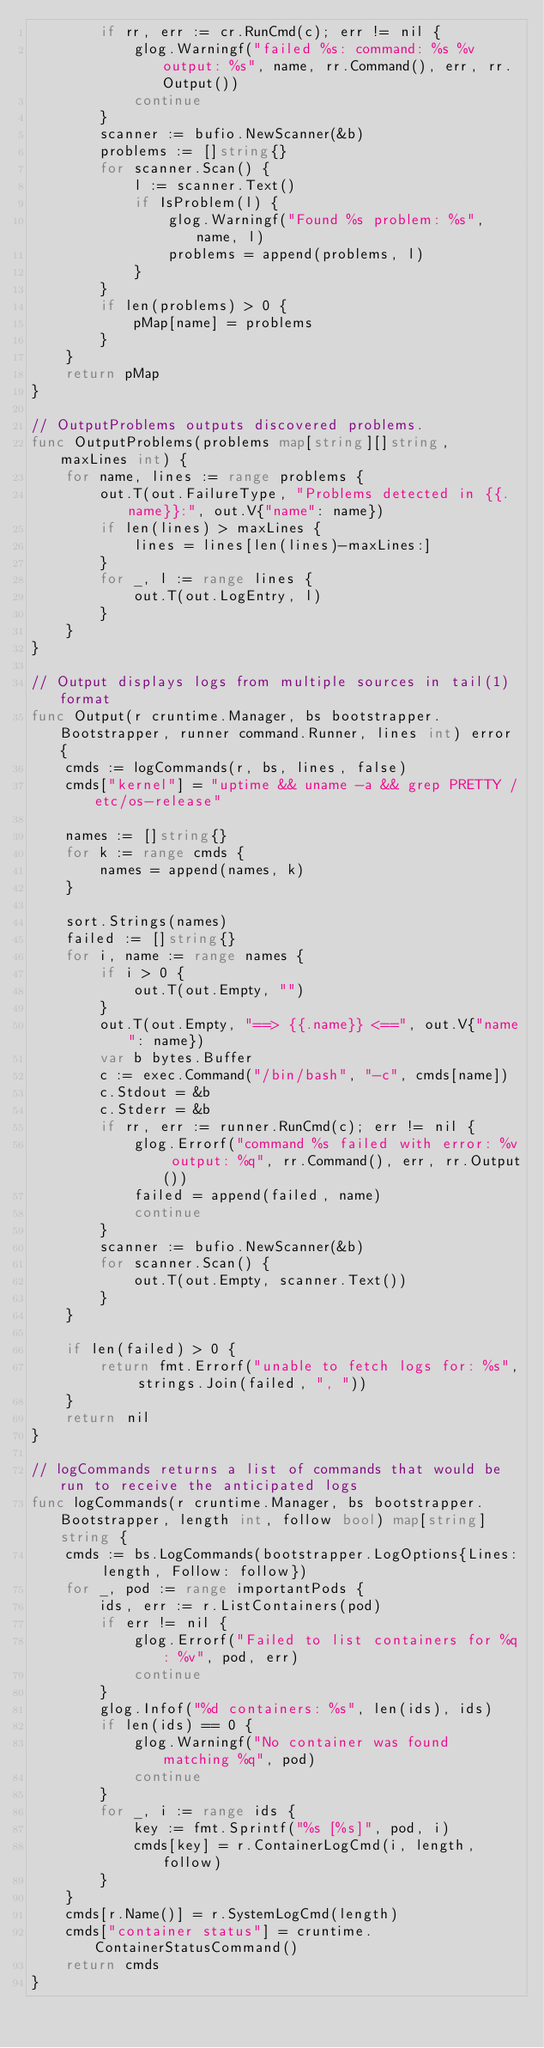Convert code to text. <code><loc_0><loc_0><loc_500><loc_500><_Go_>		if rr, err := cr.RunCmd(c); err != nil {
			glog.Warningf("failed %s: command: %s %v output: %s", name, rr.Command(), err, rr.Output())
			continue
		}
		scanner := bufio.NewScanner(&b)
		problems := []string{}
		for scanner.Scan() {
			l := scanner.Text()
			if IsProblem(l) {
				glog.Warningf("Found %s problem: %s", name, l)
				problems = append(problems, l)
			}
		}
		if len(problems) > 0 {
			pMap[name] = problems
		}
	}
	return pMap
}

// OutputProblems outputs discovered problems.
func OutputProblems(problems map[string][]string, maxLines int) {
	for name, lines := range problems {
		out.T(out.FailureType, "Problems detected in {{.name}}:", out.V{"name": name})
		if len(lines) > maxLines {
			lines = lines[len(lines)-maxLines:]
		}
		for _, l := range lines {
			out.T(out.LogEntry, l)
		}
	}
}

// Output displays logs from multiple sources in tail(1) format
func Output(r cruntime.Manager, bs bootstrapper.Bootstrapper, runner command.Runner, lines int) error {
	cmds := logCommands(r, bs, lines, false)
	cmds["kernel"] = "uptime && uname -a && grep PRETTY /etc/os-release"

	names := []string{}
	for k := range cmds {
		names = append(names, k)
	}

	sort.Strings(names)
	failed := []string{}
	for i, name := range names {
		if i > 0 {
			out.T(out.Empty, "")
		}
		out.T(out.Empty, "==> {{.name}} <==", out.V{"name": name})
		var b bytes.Buffer
		c := exec.Command("/bin/bash", "-c", cmds[name])
		c.Stdout = &b
		c.Stderr = &b
		if rr, err := runner.RunCmd(c); err != nil {
			glog.Errorf("command %s failed with error: %v output: %q", rr.Command(), err, rr.Output())
			failed = append(failed, name)
			continue
		}
		scanner := bufio.NewScanner(&b)
		for scanner.Scan() {
			out.T(out.Empty, scanner.Text())
		}
	}

	if len(failed) > 0 {
		return fmt.Errorf("unable to fetch logs for: %s", strings.Join(failed, ", "))
	}
	return nil
}

// logCommands returns a list of commands that would be run to receive the anticipated logs
func logCommands(r cruntime.Manager, bs bootstrapper.Bootstrapper, length int, follow bool) map[string]string {
	cmds := bs.LogCommands(bootstrapper.LogOptions{Lines: length, Follow: follow})
	for _, pod := range importantPods {
		ids, err := r.ListContainers(pod)
		if err != nil {
			glog.Errorf("Failed to list containers for %q: %v", pod, err)
			continue
		}
		glog.Infof("%d containers: %s", len(ids), ids)
		if len(ids) == 0 {
			glog.Warningf("No container was found matching %q", pod)
			continue
		}
		for _, i := range ids {
			key := fmt.Sprintf("%s [%s]", pod, i)
			cmds[key] = r.ContainerLogCmd(i, length, follow)
		}
	}
	cmds[r.Name()] = r.SystemLogCmd(length)
	cmds["container status"] = cruntime.ContainerStatusCommand()
	return cmds
}
</code> 